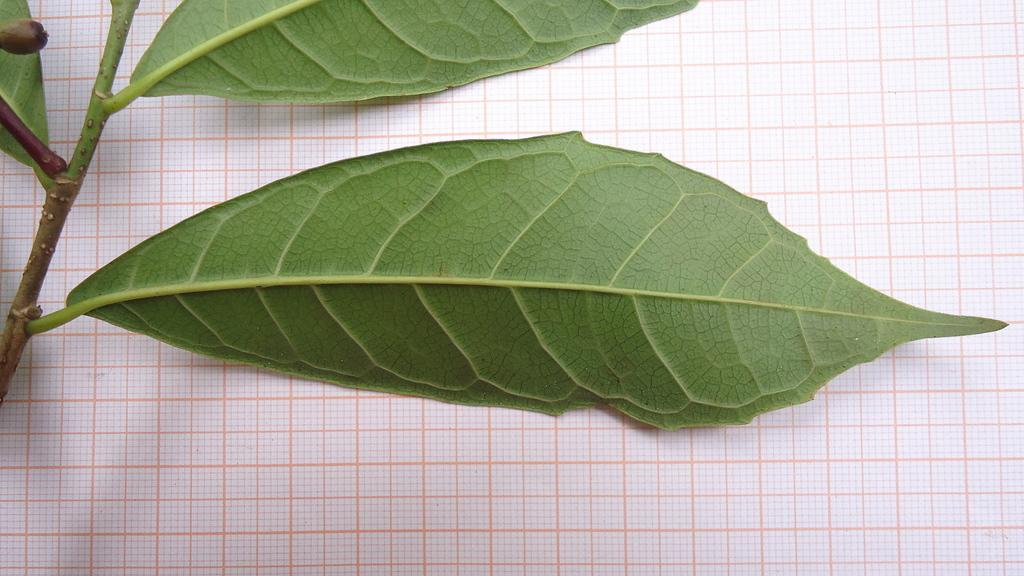What is located on the left side of the image? There is a branch of a tree on the left side of the image. What is the condition of the leaves on the branch? The leaves on the branch are green. What is hanging from the branch? The branch has a fruit. What can be seen in the background of the image? There is a cloth visible in the background of the image. What type of collar can be seen on the fruit in the image? There is no collar present on the fruit in the image. What belief system is represented by the cloth in the background? The image does not provide any information about the belief system associated with the cloth in the background. 